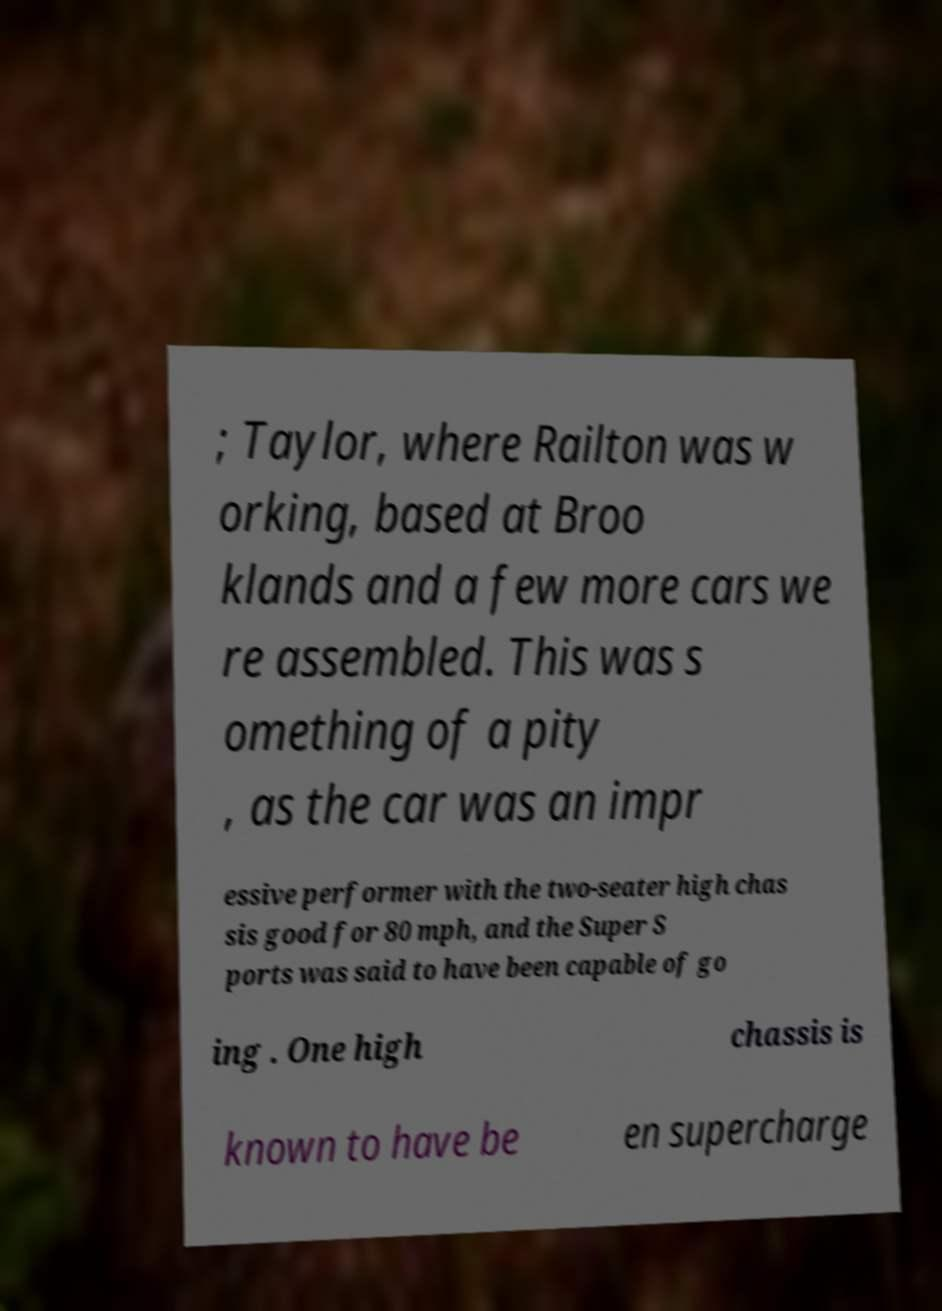Could you assist in decoding the text presented in this image and type it out clearly? ; Taylor, where Railton was w orking, based at Broo klands and a few more cars we re assembled. This was s omething of a pity , as the car was an impr essive performer with the two-seater high chas sis good for 80 mph, and the Super S ports was said to have been capable of go ing . One high chassis is known to have be en supercharge 